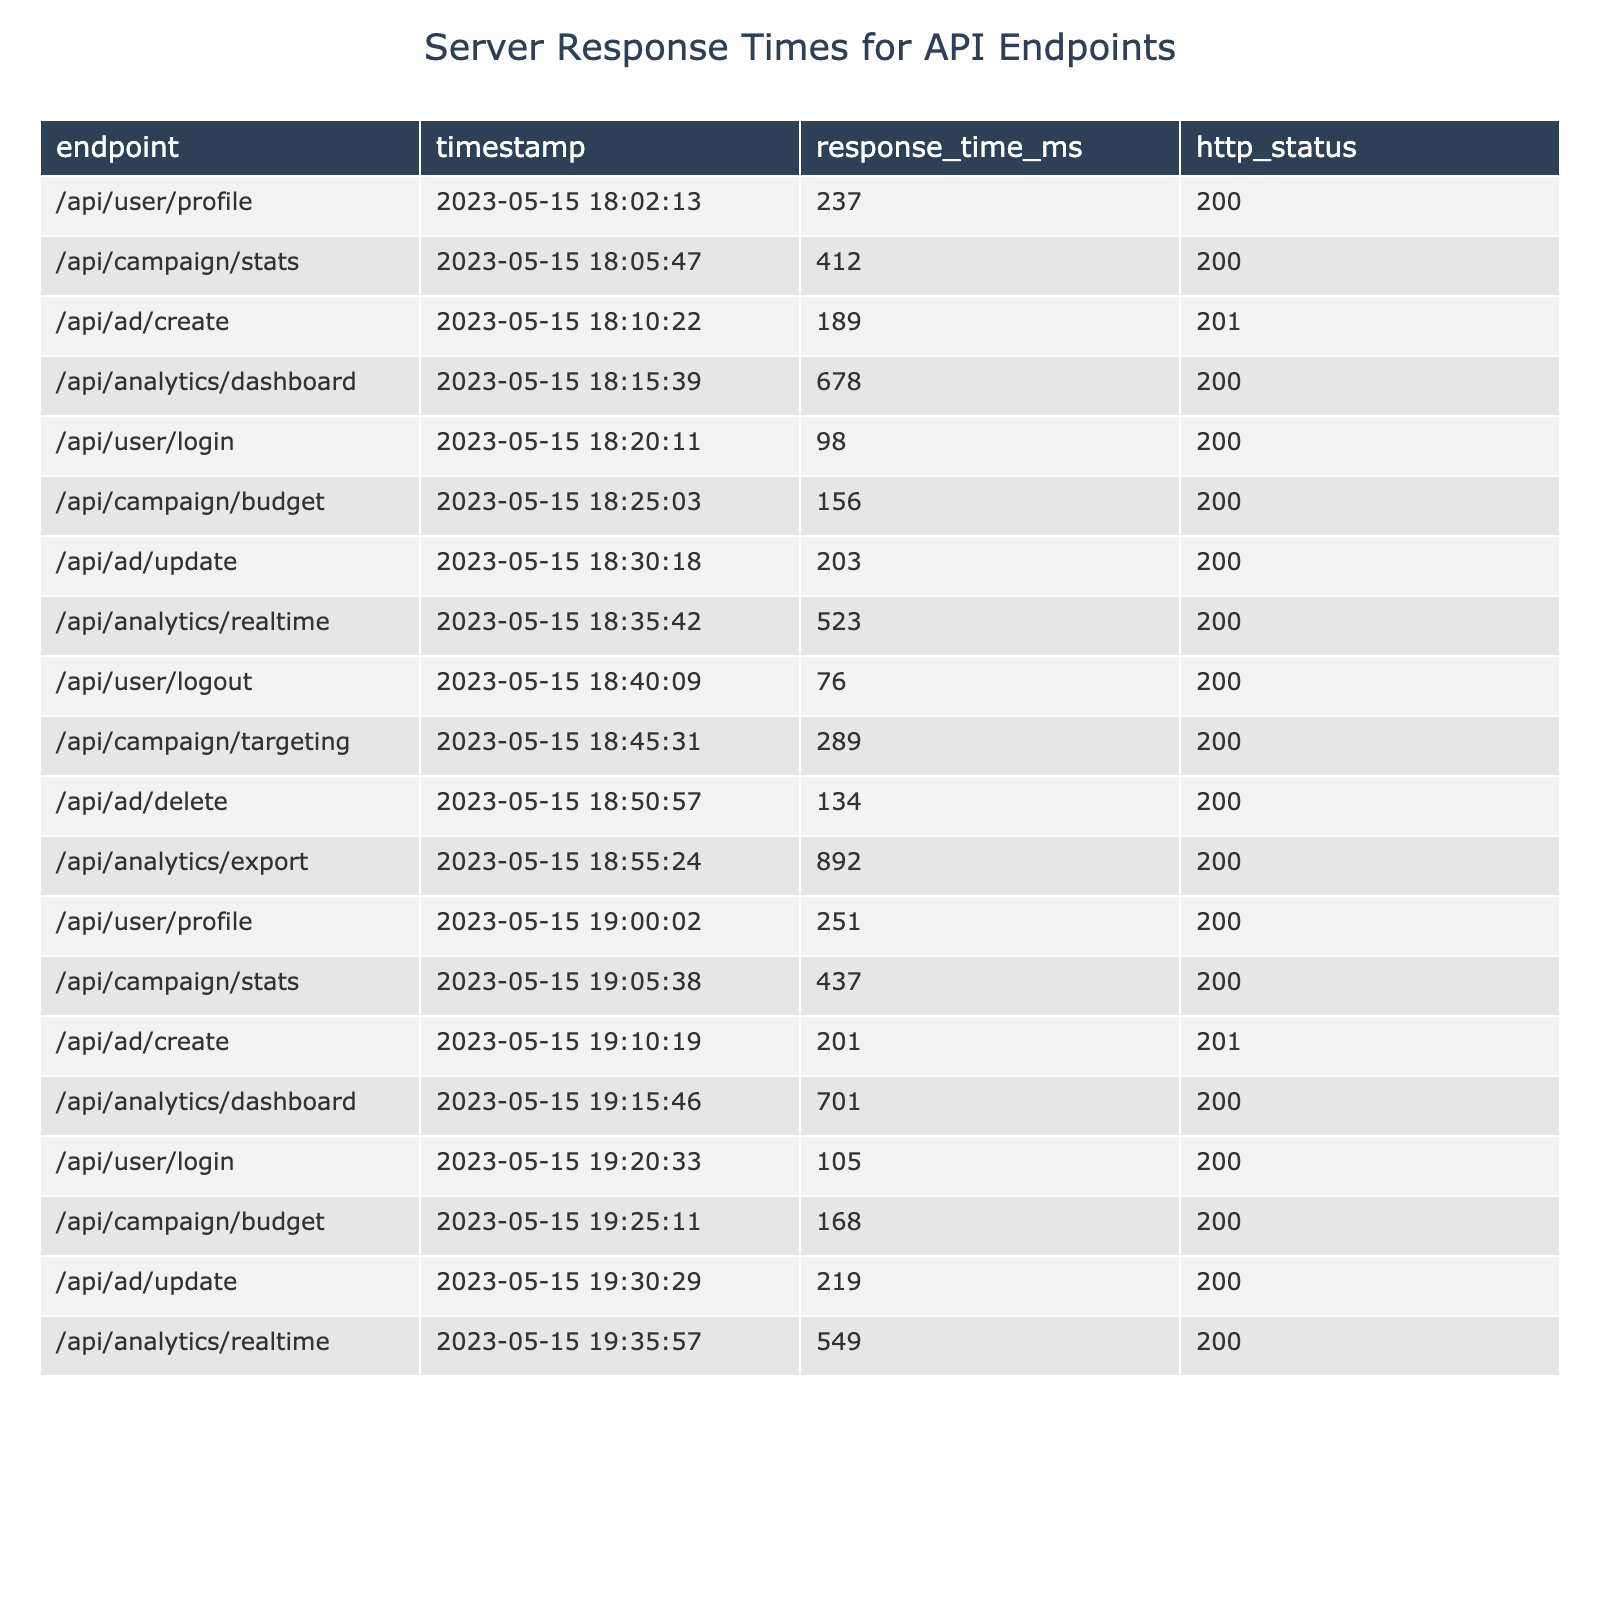What is the response time for the endpoint /api/user/profile at the timestamp 2023-05-15 19:00:02? Looking at the table, I can find the row where the endpoint is /api/user/profile and the timestamp is 2023-05-15 19:00:02. The listed response time for that entry is 251 ms.
Answer: 251 ms Which endpoint had the highest response time during the recorded timestamps? I can check the "response_time_ms" column and identify the maximum value. The highest response time in the table is 892 ms for the endpoint /api/analytics/export.
Answer: /api/analytics/export What is the average response time across all endpoints? To find the average, I sum all the response times: (237 + 412 + 189 + 678 + 98 + 156 + 203 + 523 + 76 + 289 + 134 + 892 + 251 + 437 + 201 + 701 + 105 + 168 + 219 + 549) = 4737 ms. Then, I divide that by the number of entries, which is 20. So the average response time is 4737 ms / 20 = 236.85 ms.
Answer: 236.85 ms Is there any endpoint that consistently has a response time below 100 ms? I can check each endpoint's response times and see if there are any instances where it’s below 100 ms. The endpoint /api/user/logout has a response time of 76 ms, which meets this criterion.
Answer: Yes What was the difference in response time between the /api/analytics/dashboard at 18:15:39 and at 19:15:46? I look at the response times for /api/analytics/dashboard. At the first timestamp, it is 678 ms, and at the second timestamp, it is 701 ms. The difference is 701 ms - 678 ms = 23 ms.
Answer: 23 ms How many endpoints had a response time greater than 500 ms? I will count the number of entries in the "response_time_ms" column that are greater than 500 ms. The entries are: /api/analytics/dashboard (678 ms), /api/analytics/realtime (523 ms), and /api/analytics/export (892 ms), making it a total of 3 endpoints.
Answer: 3 Is the response for the /api/ad/create endpoint within acceptable limits (assuming acceptable is under 200 ms)? I check the response times for /api/ad/create which are 189 ms (18:10:22) and 201 ms (19:10:19). Since both values exceed 200 ms for the second entry, I conclude that it does not stay within acceptable limits.
Answer: No What is the median response time of all API endpoints listed? I gather all the response times: [237, 412, 189, 678, 98, 156, 203, 523, 76, 289, 134, 892, 251, 437, 201, 701, 105, 168, 219, 549], then sort them: [76, 98, 105, 134, 156, 168, 189, 201, 203, 219, 237, 251, 289, 412, 437, 523, 549, 678, 701, 892]. The median is the average of the 10th and 11th values: (219 + 237)/2 = 228.
Answer: 228 ms Which endpoint has the least amount of recorded timestamps? I can count the occurrences of each endpoint. Every endpoint appears twice except for /api/ad/delete, which only appears once. Thus, it has the least.
Answer: /api/ad/delete Did the response time of /api/campaign/budget increase or decrease from the first record to the second? Looking at the timestamps for /api/campaign/budget, the first response time is 156 ms (at 18:25:03) and the second is 168 ms (at 19:25:11). Since 168 ms > 156 ms, we see an increase in response time.
Answer: Increase 